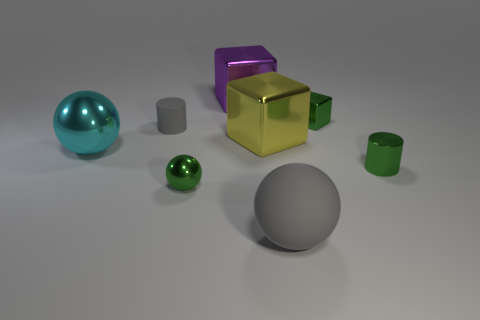Subtract all yellow cylinders. Subtract all yellow spheres. How many cylinders are left? 2 Add 1 big yellow objects. How many objects exist? 9 Subtract all cubes. How many objects are left? 5 Add 8 large cyan shiny balls. How many large cyan shiny balls are left? 9 Add 4 large yellow metal blocks. How many large yellow metal blocks exist? 5 Subtract 1 gray spheres. How many objects are left? 7 Subtract all cylinders. Subtract all small shiny cubes. How many objects are left? 5 